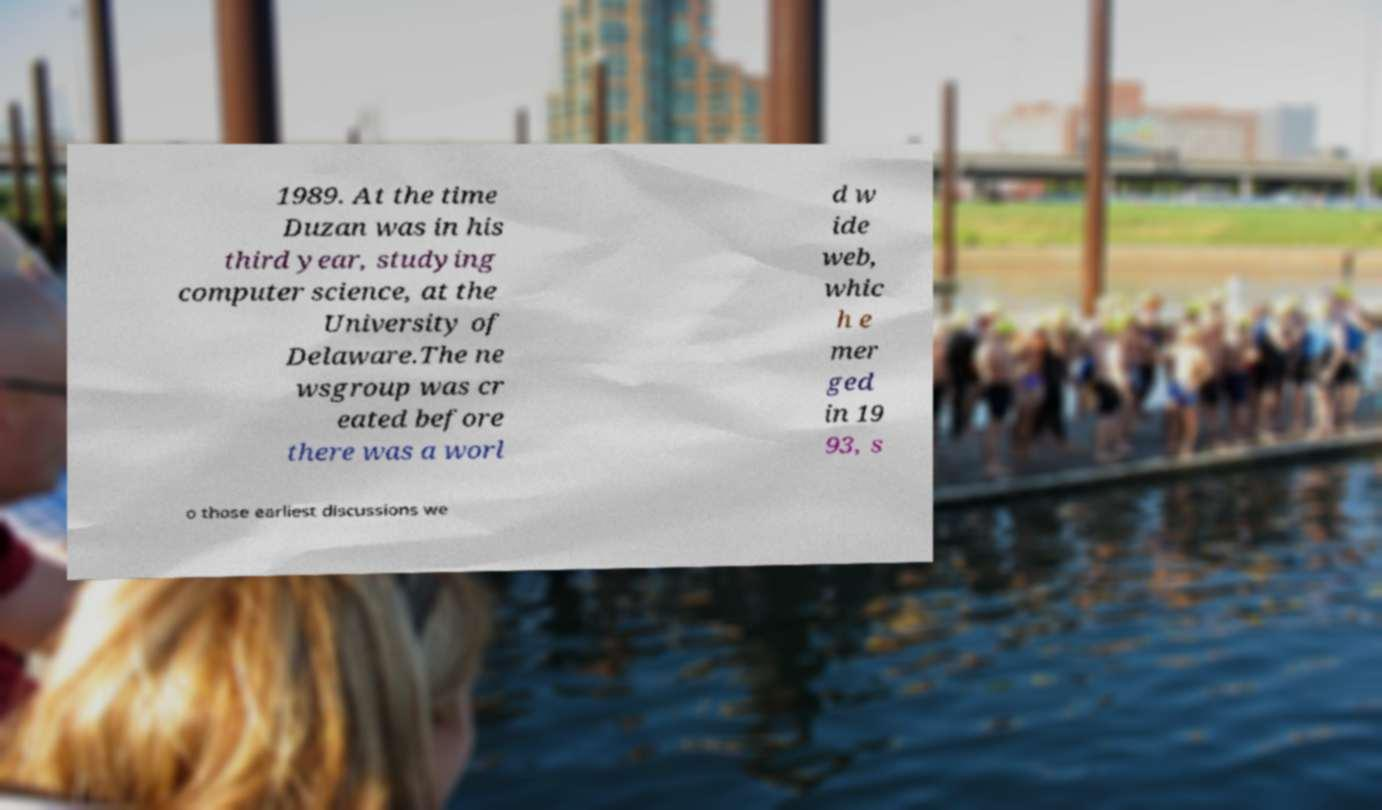Could you extract and type out the text from this image? 1989. At the time Duzan was in his third year, studying computer science, at the University of Delaware.The ne wsgroup was cr eated before there was a worl d w ide web, whic h e mer ged in 19 93, s o those earliest discussions we 